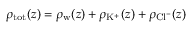<formula> <loc_0><loc_0><loc_500><loc_500>\rho _ { t o t } ( z ) = \rho _ { w } ( z ) + \rho _ { K ^ { + } } ( z ) + \rho _ { C l ^ { - } } ( z )</formula> 